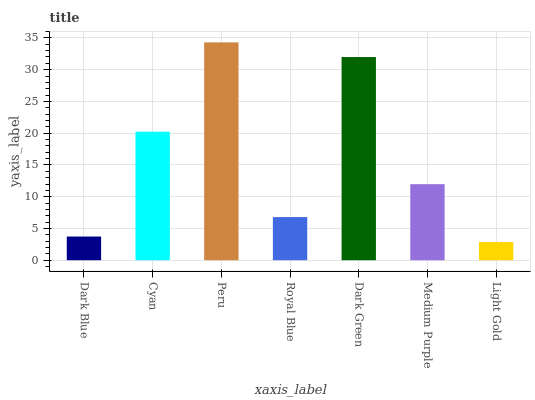Is Cyan the minimum?
Answer yes or no. No. Is Cyan the maximum?
Answer yes or no. No. Is Cyan greater than Dark Blue?
Answer yes or no. Yes. Is Dark Blue less than Cyan?
Answer yes or no. Yes. Is Dark Blue greater than Cyan?
Answer yes or no. No. Is Cyan less than Dark Blue?
Answer yes or no. No. Is Medium Purple the high median?
Answer yes or no. Yes. Is Medium Purple the low median?
Answer yes or no. Yes. Is Royal Blue the high median?
Answer yes or no. No. Is Dark Blue the low median?
Answer yes or no. No. 